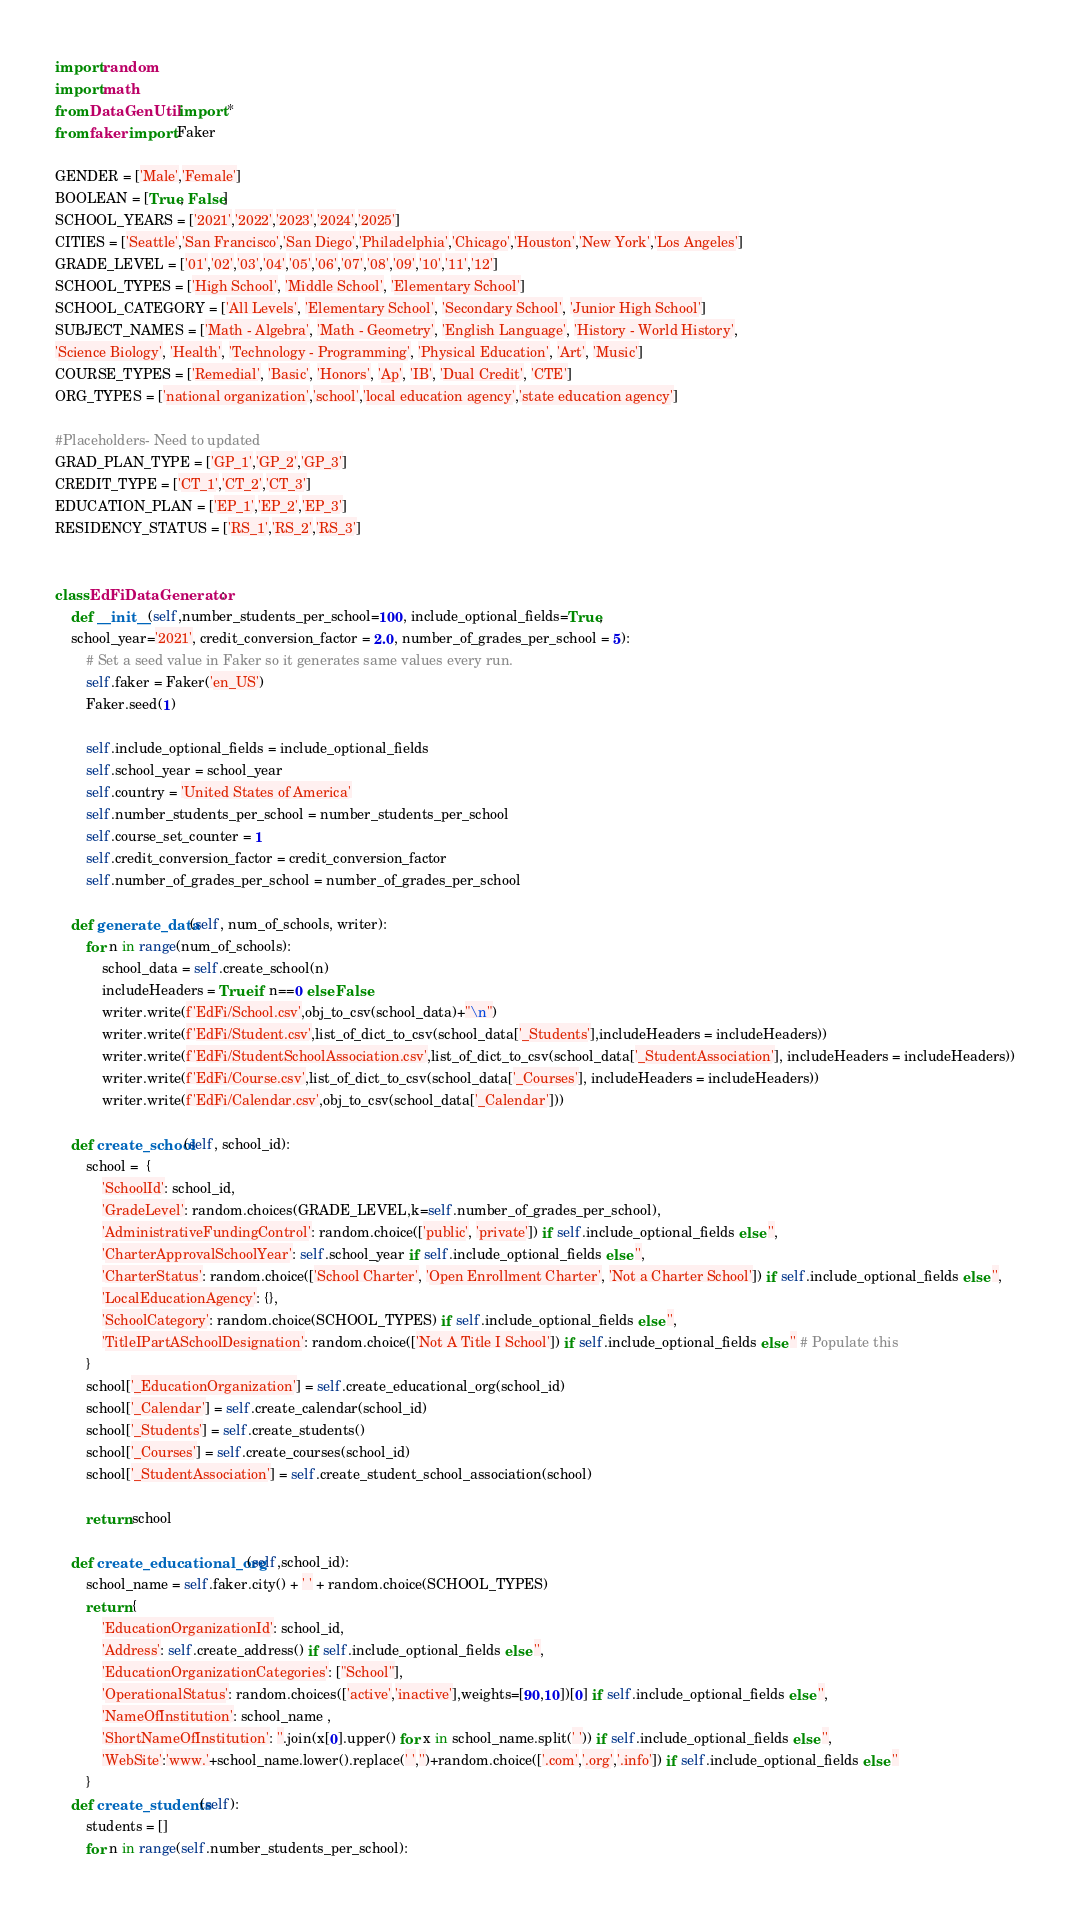Convert code to text. <code><loc_0><loc_0><loc_500><loc_500><_Python_>import random
import math
from DataGenUtil import *
from faker import Faker

GENDER = ['Male','Female']
BOOLEAN = [True, False]
SCHOOL_YEARS = ['2021','2022','2023','2024','2025']
CITIES = ['Seattle','San Francisco','San Diego','Philadelphia','Chicago','Houston','New York','Los Angeles']
GRADE_LEVEL = ['01','02','03','04','05','06','07','08','09','10','11','12']
SCHOOL_TYPES = ['High School', 'Middle School', 'Elementary School']
SCHOOL_CATEGORY = ['All Levels', 'Elementary School', 'Secondary School', 'Junior High School']
SUBJECT_NAMES = ['Math - Algebra', 'Math - Geometry', 'English Language', 'History - World History',
'Science Biology', 'Health', 'Technology - Programming', 'Physical Education', 'Art', 'Music']
COURSE_TYPES = ['Remedial', 'Basic', 'Honors', 'Ap', 'IB', 'Dual Credit', 'CTE']
ORG_TYPES = ['national organization','school','local education agency','state education agency']

#Placeholders- Need to updated
GRAD_PLAN_TYPE = ['GP_1','GP_2','GP_3']
CREDIT_TYPE = ['CT_1','CT_2','CT_3']
EDUCATION_PLAN = ['EP_1','EP_2','EP_3']
RESIDENCY_STATUS = ['RS_1','RS_2','RS_3']


class EdFiDataGenerator:
    def __init__(self,number_students_per_school=100, include_optional_fields=True, 
    school_year='2021', credit_conversion_factor = 2.0, number_of_grades_per_school = 5):
        # Set a seed value in Faker so it generates same values every run.
        self.faker = Faker('en_US')
        Faker.seed(1)

        self.include_optional_fields = include_optional_fields
        self.school_year = school_year
        self.country = 'United States of America'
        self.number_students_per_school = number_students_per_school
        self.course_set_counter = 1
        self.credit_conversion_factor = credit_conversion_factor
        self.number_of_grades_per_school = number_of_grades_per_school

    def generate_data(self, num_of_schools, writer):
        for n in range(num_of_schools):
            school_data = self.create_school(n)
            includeHeaders = True if n==0 else False
            writer.write(f'EdFi/School.csv',obj_to_csv(school_data)+"\n")
            writer.write(f'EdFi/Student.csv',list_of_dict_to_csv(school_data['_Students'],includeHeaders = includeHeaders))
            writer.write(f'EdFi/StudentSchoolAssociation.csv',list_of_dict_to_csv(school_data['_StudentAssociation'], includeHeaders = includeHeaders))
            writer.write(f'EdFi/Course.csv',list_of_dict_to_csv(school_data['_Courses'], includeHeaders = includeHeaders))
            writer.write(f'EdFi/Calendar.csv',obj_to_csv(school_data['_Calendar']))

    def create_school(self, school_id):
        school =  {
            'SchoolId': school_id,
            'GradeLevel': random.choices(GRADE_LEVEL,k=self.number_of_grades_per_school),
            'AdministrativeFundingControl': random.choice(['public', 'private']) if self.include_optional_fields else '',
            'CharterApprovalSchoolYear': self.school_year if self.include_optional_fields else '',
            'CharterStatus': random.choice(['School Charter', 'Open Enrollment Charter', 'Not a Charter School']) if self.include_optional_fields else '',
            'LocalEducationAgency': {},
            'SchoolCategory': random.choice(SCHOOL_TYPES) if self.include_optional_fields else '',
            'TitleIPartASchoolDesignation': random.choice(['Not A Title I School']) if self.include_optional_fields else '' # Populate this
        }
        school['_EducationOrganization'] = self.create_educational_org(school_id)
        school['_Calendar'] = self.create_calendar(school_id)
        school['_Students'] = self.create_students()
        school['_Courses'] = self.create_courses(school_id)
        school['_StudentAssociation'] = self.create_student_school_association(school)
        
        return school

    def create_educational_org(self,school_id):
        school_name = self.faker.city() + ' ' + random.choice(SCHOOL_TYPES)
        return {
            'EducationOrganizationId': school_id,
            'Address': self.create_address() if self.include_optional_fields else '',
            'EducationOrganizationCategories': ["School"],
            'OperationalStatus': random.choices(['active','inactive'],weights=[90,10])[0] if self.include_optional_fields else '',
            'NameOfInstitution': school_name ,
            'ShortNameOfInstitution': ''.join(x[0].upper() for x in school_name.split(' ')) if self.include_optional_fields else '',
            'WebSite':'www.'+school_name.lower().replace(' ','')+random.choice(['.com','.org','.info']) if self.include_optional_fields else ''
        }
    def create_students(self):
        students = []
        for n in range(self.number_students_per_school):</code> 